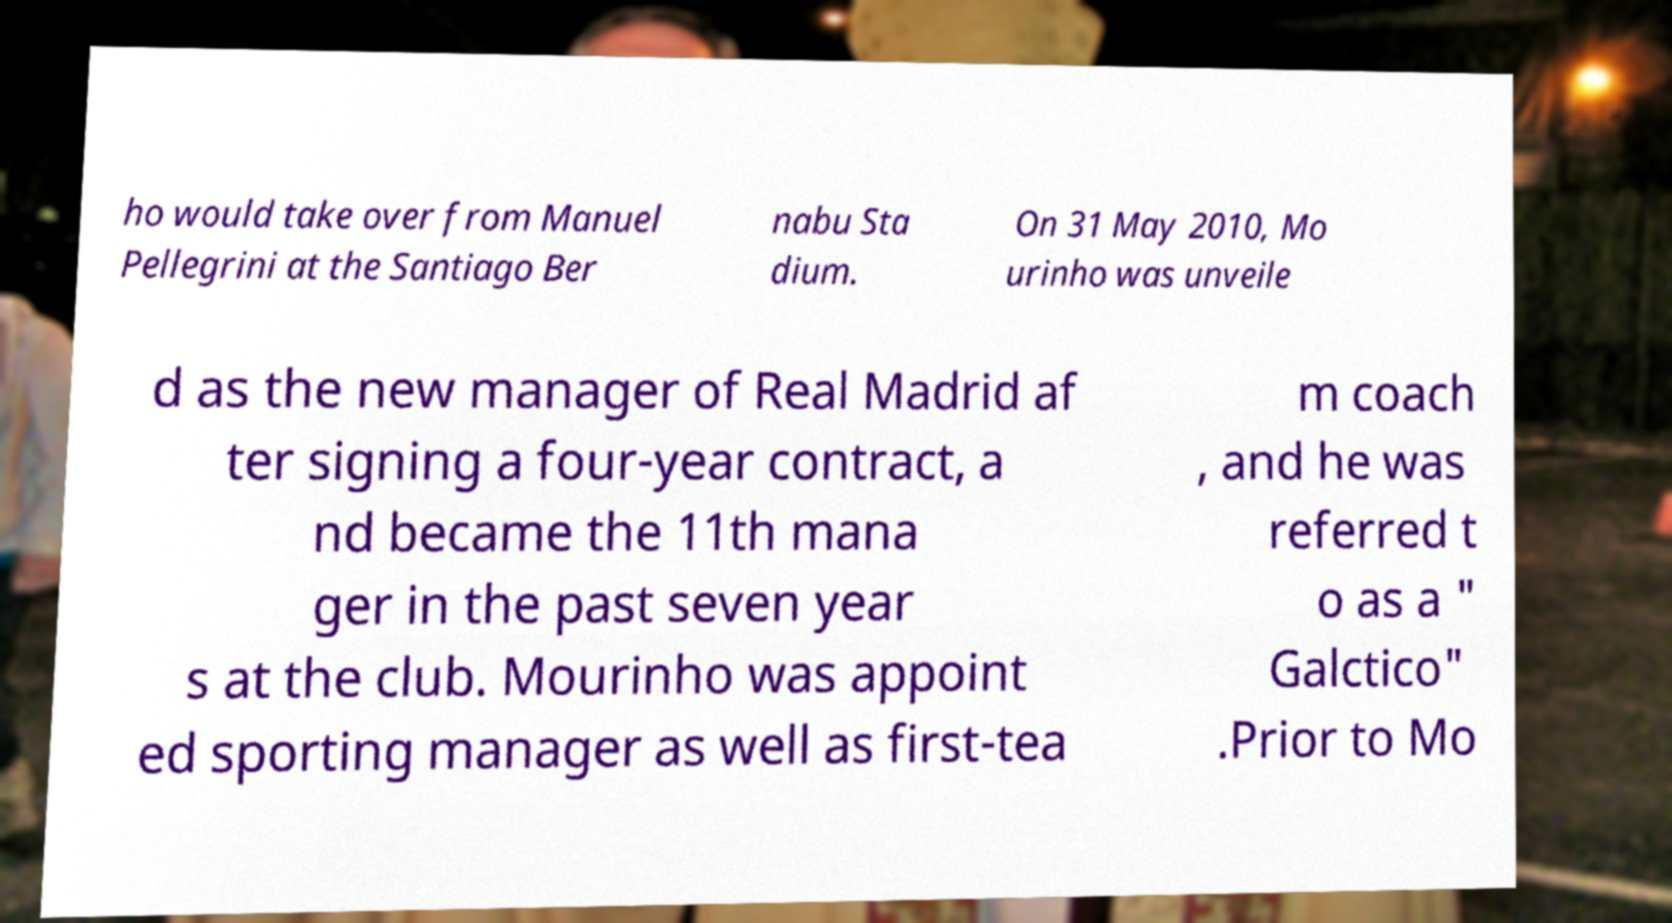There's text embedded in this image that I need extracted. Can you transcribe it verbatim? ho would take over from Manuel Pellegrini at the Santiago Ber nabu Sta dium. On 31 May 2010, Mo urinho was unveile d as the new manager of Real Madrid af ter signing a four-year contract, a nd became the 11th mana ger in the past seven year s at the club. Mourinho was appoint ed sporting manager as well as first-tea m coach , and he was referred t o as a " Galctico" .Prior to Mo 